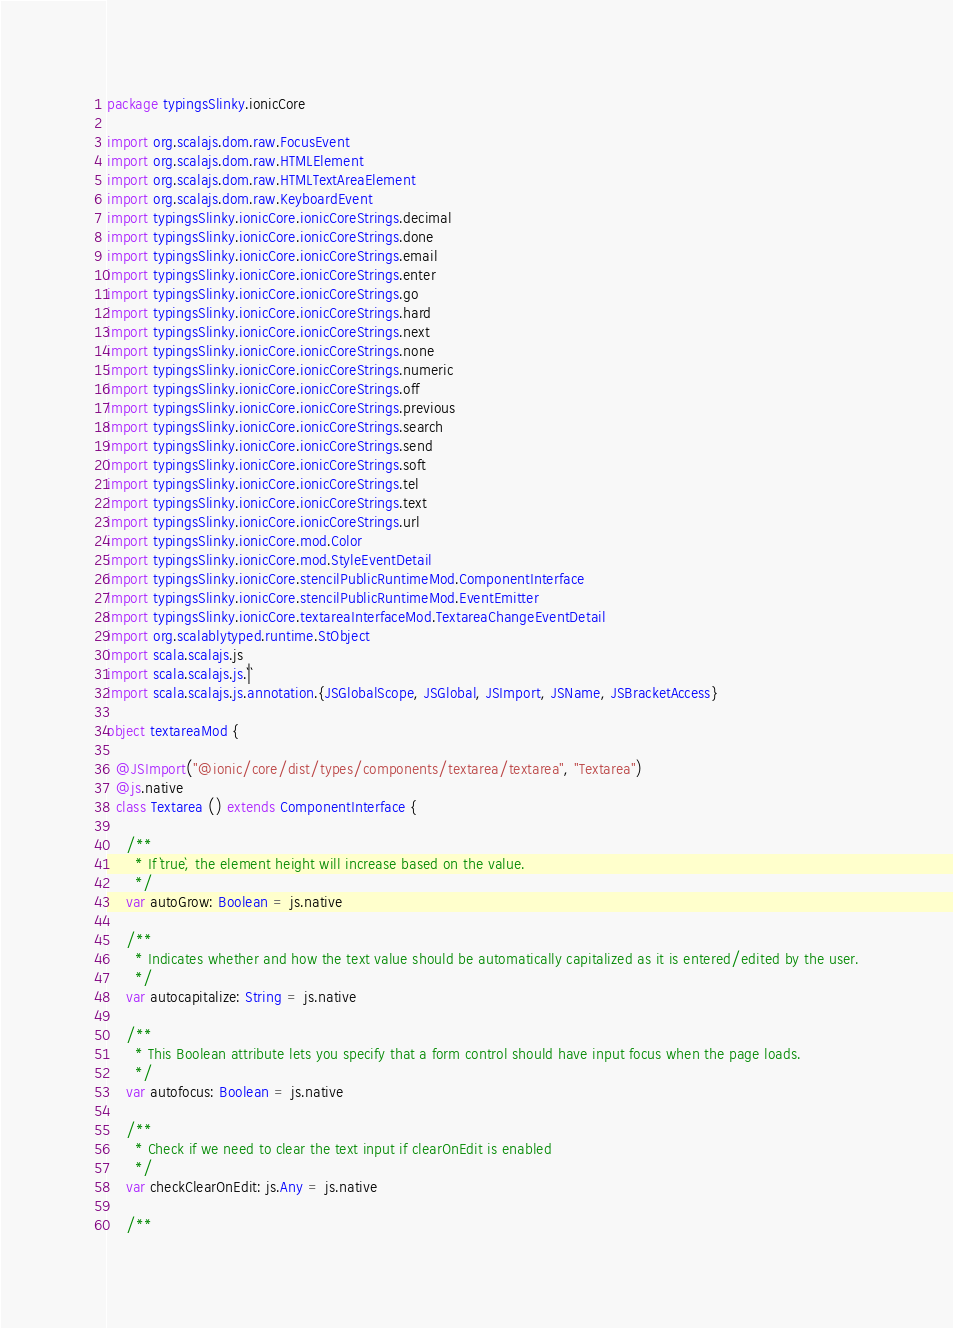<code> <loc_0><loc_0><loc_500><loc_500><_Scala_>package typingsSlinky.ionicCore

import org.scalajs.dom.raw.FocusEvent
import org.scalajs.dom.raw.HTMLElement
import org.scalajs.dom.raw.HTMLTextAreaElement
import org.scalajs.dom.raw.KeyboardEvent
import typingsSlinky.ionicCore.ionicCoreStrings.decimal
import typingsSlinky.ionicCore.ionicCoreStrings.done
import typingsSlinky.ionicCore.ionicCoreStrings.email
import typingsSlinky.ionicCore.ionicCoreStrings.enter
import typingsSlinky.ionicCore.ionicCoreStrings.go
import typingsSlinky.ionicCore.ionicCoreStrings.hard
import typingsSlinky.ionicCore.ionicCoreStrings.next
import typingsSlinky.ionicCore.ionicCoreStrings.none
import typingsSlinky.ionicCore.ionicCoreStrings.numeric
import typingsSlinky.ionicCore.ionicCoreStrings.off
import typingsSlinky.ionicCore.ionicCoreStrings.previous
import typingsSlinky.ionicCore.ionicCoreStrings.search
import typingsSlinky.ionicCore.ionicCoreStrings.send
import typingsSlinky.ionicCore.ionicCoreStrings.soft
import typingsSlinky.ionicCore.ionicCoreStrings.tel
import typingsSlinky.ionicCore.ionicCoreStrings.text
import typingsSlinky.ionicCore.ionicCoreStrings.url
import typingsSlinky.ionicCore.mod.Color
import typingsSlinky.ionicCore.mod.StyleEventDetail
import typingsSlinky.ionicCore.stencilPublicRuntimeMod.ComponentInterface
import typingsSlinky.ionicCore.stencilPublicRuntimeMod.EventEmitter
import typingsSlinky.ionicCore.textareaInterfaceMod.TextareaChangeEventDetail
import org.scalablytyped.runtime.StObject
import scala.scalajs.js
import scala.scalajs.js.`|`
import scala.scalajs.js.annotation.{JSGlobalScope, JSGlobal, JSImport, JSName, JSBracketAccess}

object textareaMod {
  
  @JSImport("@ionic/core/dist/types/components/textarea/textarea", "Textarea")
  @js.native
  class Textarea () extends ComponentInterface {
    
    /**
      * If `true`, the element height will increase based on the value.
      */
    var autoGrow: Boolean = js.native
    
    /**
      * Indicates whether and how the text value should be automatically capitalized as it is entered/edited by the user.
      */
    var autocapitalize: String = js.native
    
    /**
      * This Boolean attribute lets you specify that a form control should have input focus when the page loads.
      */
    var autofocus: Boolean = js.native
    
    /**
      * Check if we need to clear the text input if clearOnEdit is enabled
      */
    var checkClearOnEdit: js.Any = js.native
    
    /**</code> 